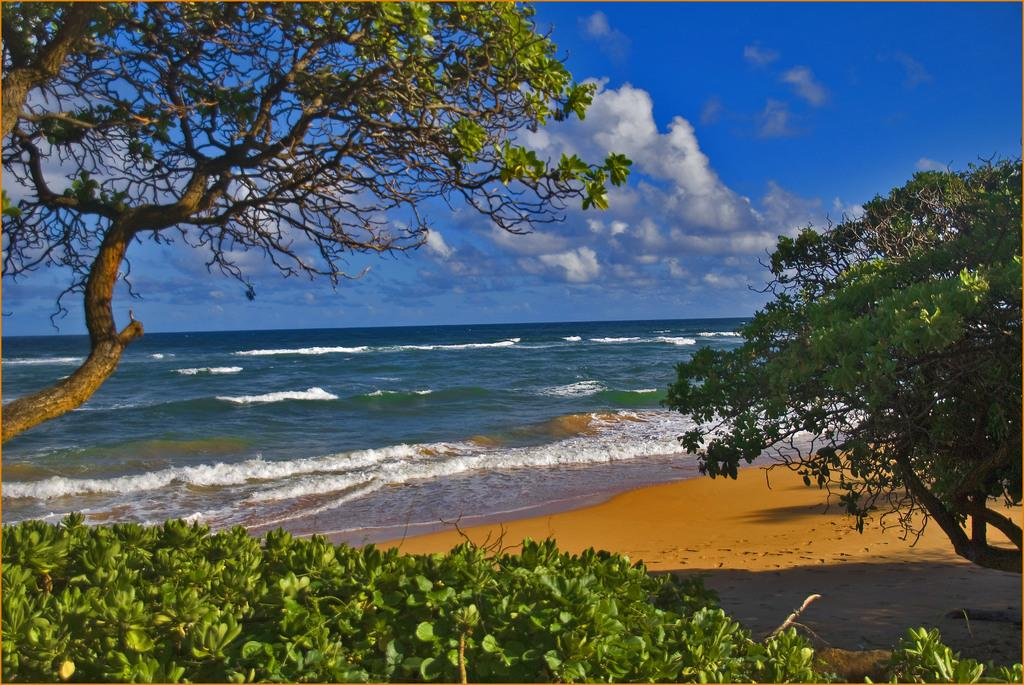What is the main feature of the image? There is a large water body in the image. What type of vegetation can be seen in the image? There are trees and plants in the image. What is visible in the background of the image? The sky is visible in the image. How would you describe the sky in the image? The sky appears cloudy in the image. Where is the playground located in the image? There is no playground present in the image. What type of pie is being served at the water's edge in the image? There is no pie visible in the image. 